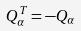Convert formula to latex. <formula><loc_0><loc_0><loc_500><loc_500>Q _ { \alpha } ^ { T } = - Q _ { \alpha }</formula> 